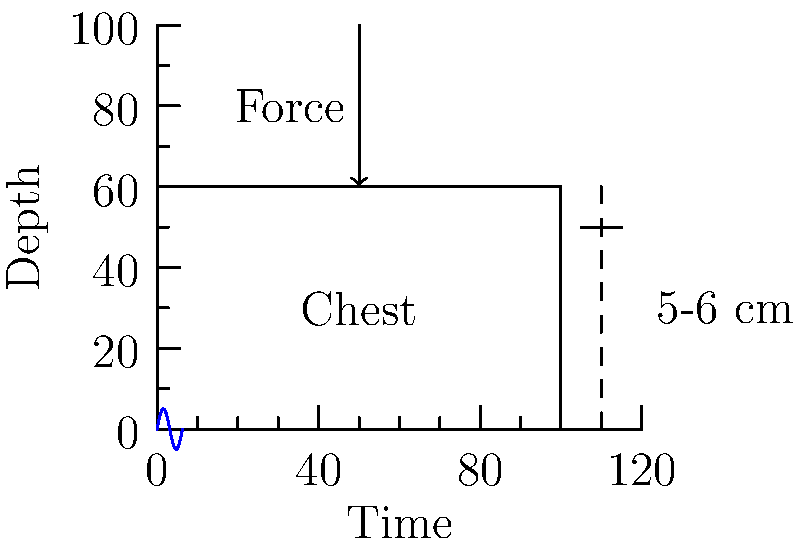In a TV medical drama, a doctor performs CPR on a patient. The show depicts chest compressions at a rate of 100 per minute, with a compression depth of 2 inches. Based on current guidelines and biomechanical principles, what aspect of this CPR technique is inaccurate, and how might it affect the procedure's effectiveness? Let's analyze this step-by-step:

1. Compression rate:
   - The depicted rate of 100 compressions per minute is within the correct range.
   - Current guidelines recommend a rate of 100-120 compressions per minute.

2. Compression depth:
   - The show depicts a depth of 2 inches (approximately 5 cm).
   - Current guidelines recommend a depth of at least 2 inches (5 cm) but no more than 2.4 inches (6 cm) for adults.

3. Biomechanical principles:
   - Effective CPR relies on creating sufficient intrathoracic pressure to circulate blood.
   - The depth of compression directly affects the amount of blood ejected from the heart with each compression.

4. Effectiveness analysis:
   - While 2 inches is the minimum recommended depth, it may not be optimal for all patients.
   - Larger or more muscular individuals might require compressions closer to the 2.4-inch (6 cm) maximum for optimal blood flow.
   - Compressions that are too shallow (less than 2 inches) are known to be less effective in generating adequate blood flow.

5. Impact on procedure effectiveness:
   - By consistently using the minimum depth, the TV show's depiction might underestimate the importance of adjusting compression depth to the individual patient.
   - This could lead to suboptimal blood flow in some patients, potentially reducing the effectiveness of the CPR.

6. Accuracy in medical dramas:
   - While the depicted technique is not strictly incorrect, it oversimplifies the nuanced approach required in real-life CPR.
   - Medical professionals would typically assess the patient's body type and adjust compression depth accordingly within the recommended range.

In conclusion, while the compression depth shown is not technically incorrect, it represents the minimum recommended depth and may not be optimal for all patients. This simplification could potentially mislead viewers about the importance of tailoring CPR technique to individual patients for maximum effectiveness.
Answer: Compression depth of 2 inches is the minimum; optimal depth may vary up to 2.4 inches based on patient physiology. 